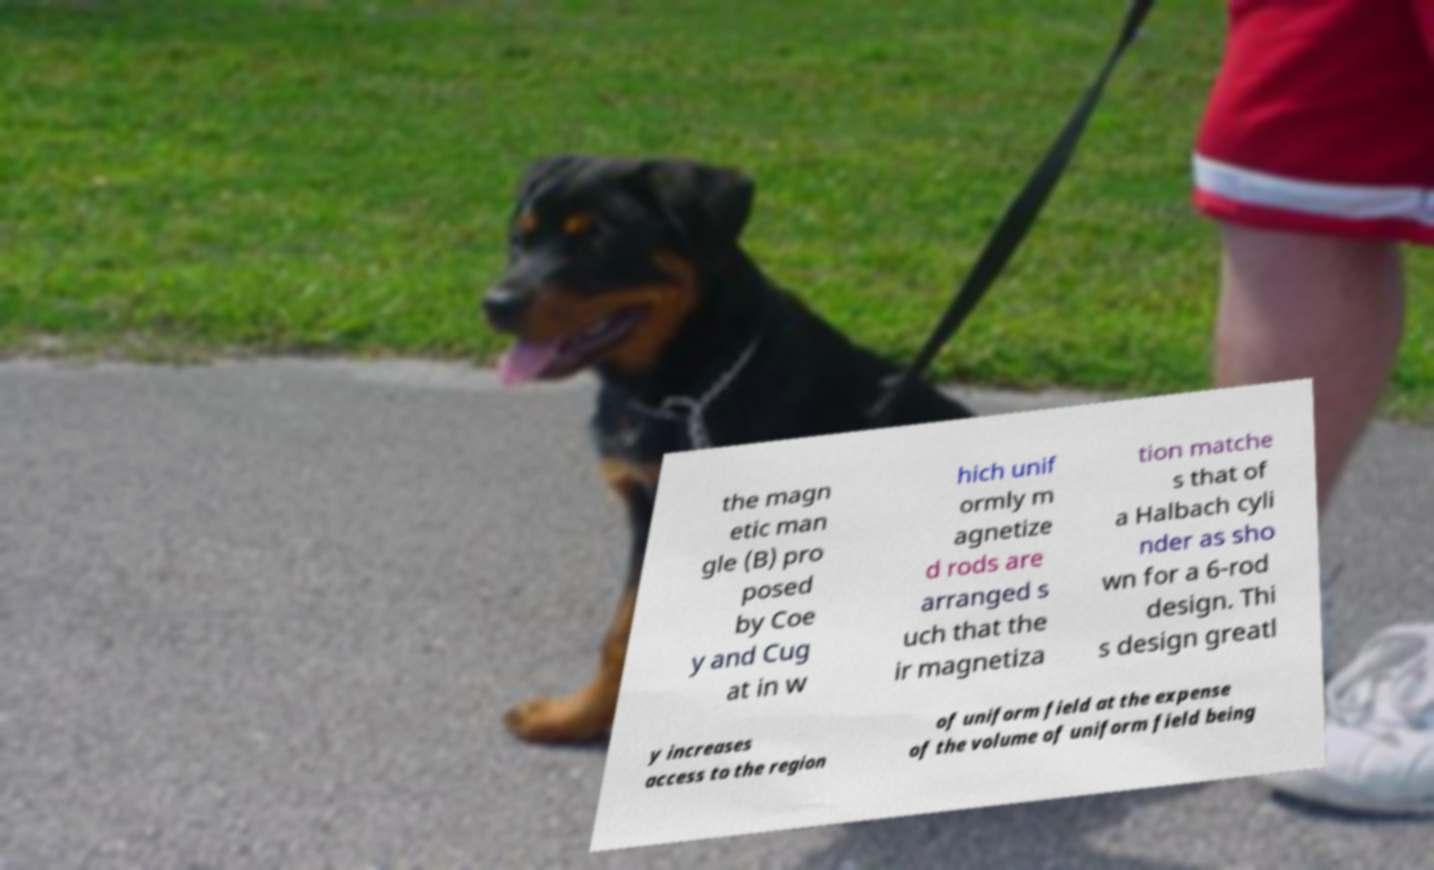For documentation purposes, I need the text within this image transcribed. Could you provide that? the magn etic man gle (B) pro posed by Coe y and Cug at in w hich unif ormly m agnetize d rods are arranged s uch that the ir magnetiza tion matche s that of a Halbach cyli nder as sho wn for a 6-rod design. Thi s design greatl y increases access to the region of uniform field at the expense of the volume of uniform field being 